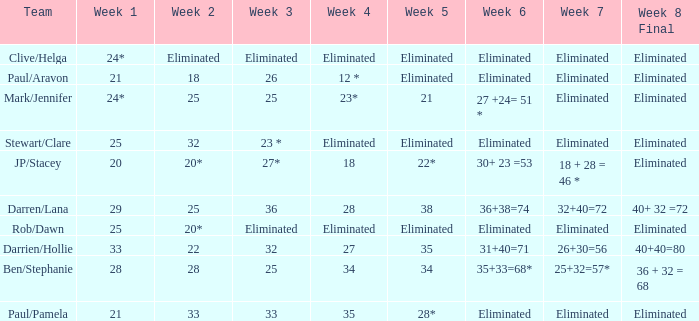Name the team for week 1 of 33 Darrien/Hollie. 